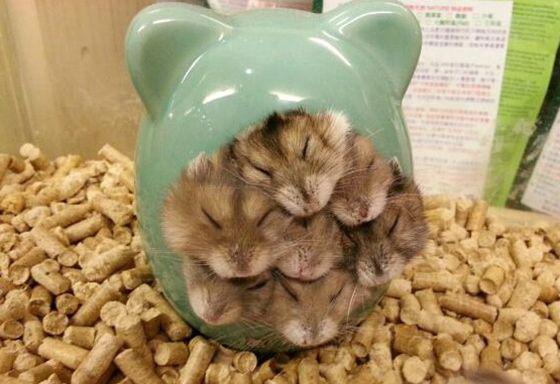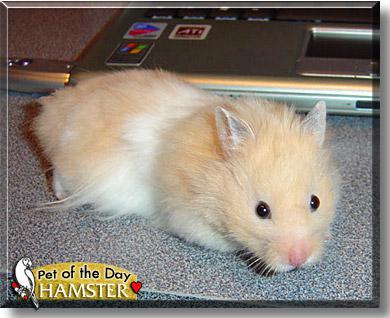The first image is the image on the left, the second image is the image on the right. Examine the images to the left and right. Is the description "At least one animal is outside." accurate? Answer yes or no. No. The first image is the image on the left, the second image is the image on the right. Assess this claim about the two images: "The left image contains at least seven rodents.". Correct or not? Answer yes or no. Yes. 